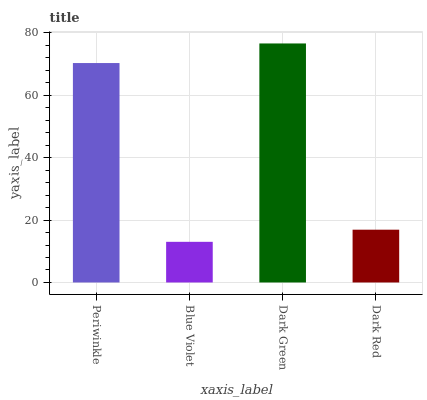Is Blue Violet the minimum?
Answer yes or no. Yes. Is Dark Green the maximum?
Answer yes or no. Yes. Is Dark Green the minimum?
Answer yes or no. No. Is Blue Violet the maximum?
Answer yes or no. No. Is Dark Green greater than Blue Violet?
Answer yes or no. Yes. Is Blue Violet less than Dark Green?
Answer yes or no. Yes. Is Blue Violet greater than Dark Green?
Answer yes or no. No. Is Dark Green less than Blue Violet?
Answer yes or no. No. Is Periwinkle the high median?
Answer yes or no. Yes. Is Dark Red the low median?
Answer yes or no. Yes. Is Dark Red the high median?
Answer yes or no. No. Is Dark Green the low median?
Answer yes or no. No. 